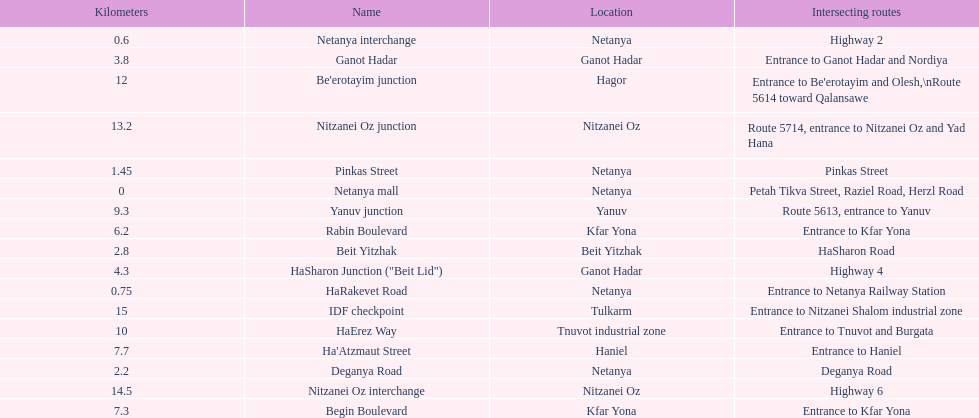After you complete deganya road, what portion comes next? Beit Yitzhak. 